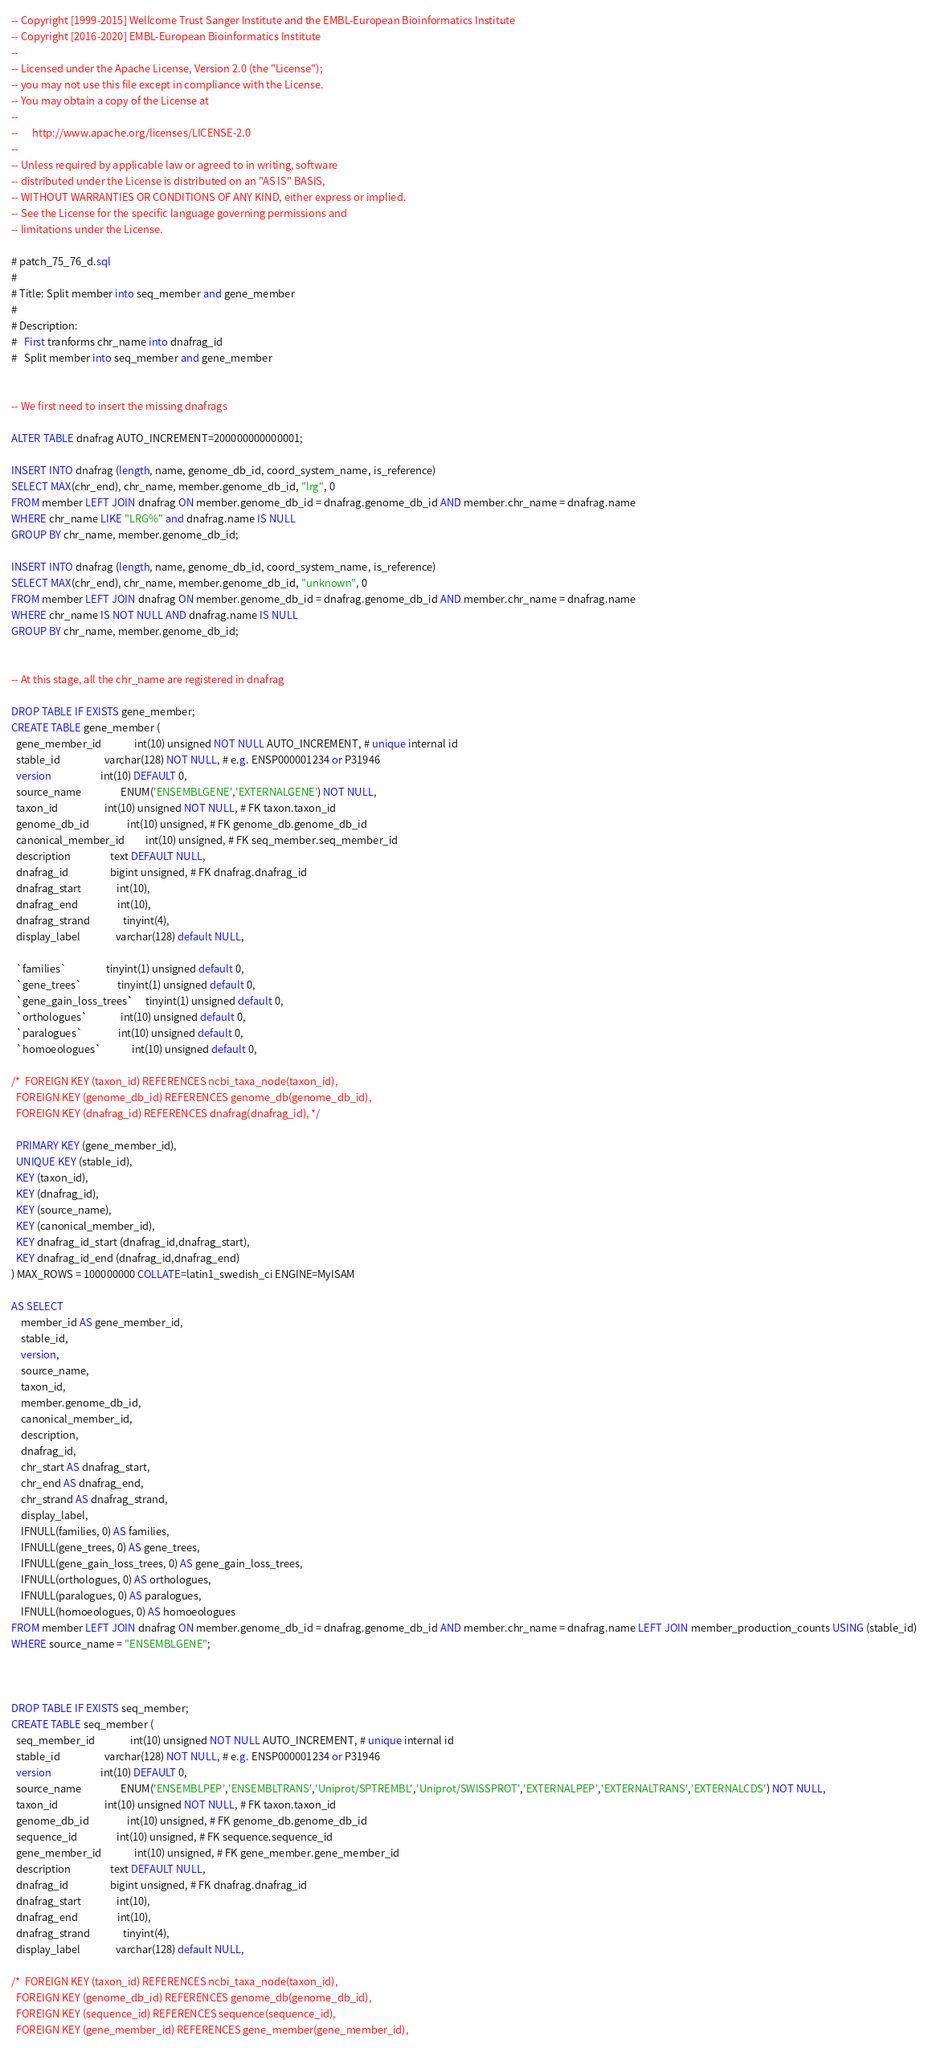Convert code to text. <code><loc_0><loc_0><loc_500><loc_500><_SQL_>-- Copyright [1999-2015] Wellcome Trust Sanger Institute and the EMBL-European Bioinformatics Institute
-- Copyright [2016-2020] EMBL-European Bioinformatics Institute
-- 
-- Licensed under the Apache License, Version 2.0 (the "License");
-- you may not use this file except in compliance with the License.
-- You may obtain a copy of the License at
-- 
--      http://www.apache.org/licenses/LICENSE-2.0
-- 
-- Unless required by applicable law or agreed to in writing, software
-- distributed under the License is distributed on an "AS IS" BASIS,
-- WITHOUT WARRANTIES OR CONDITIONS OF ANY KIND, either express or implied.
-- See the License for the specific language governing permissions and
-- limitations under the License.

# patch_75_76_d.sql
#
# Title: Split member into seq_member and gene_member
#
# Description:
#   First tranforms chr_name into dnafrag_id
#   Split member into seq_member and gene_member


-- We first need to insert the missing dnafrags

ALTER TABLE dnafrag AUTO_INCREMENT=200000000000001;

INSERT INTO dnafrag (length, name, genome_db_id, coord_system_name, is_reference)
SELECT MAX(chr_end), chr_name, member.genome_db_id, "lrg", 0
FROM member LEFT JOIN dnafrag ON member.genome_db_id = dnafrag.genome_db_id AND member.chr_name = dnafrag.name
WHERE chr_name LIKE "LRG%" and dnafrag.name IS NULL
GROUP BY chr_name, member.genome_db_id;

INSERT INTO dnafrag (length, name, genome_db_id, coord_system_name, is_reference)
SELECT MAX(chr_end), chr_name, member.genome_db_id, "unknown", 0
FROM member LEFT JOIN dnafrag ON member.genome_db_id = dnafrag.genome_db_id AND member.chr_name = dnafrag.name
WHERE chr_name IS NOT NULL AND dnafrag.name IS NULL
GROUP BY chr_name, member.genome_db_id;


-- At this stage, all the chr_name are registered in dnafrag

DROP TABLE IF EXISTS gene_member;
CREATE TABLE gene_member (
  gene_member_id              int(10) unsigned NOT NULL AUTO_INCREMENT, # unique internal id
  stable_id                   varchar(128) NOT NULL, # e.g. ENSP000001234 or P31946
  version                     int(10) DEFAULT 0,
  source_name                 ENUM('ENSEMBLGENE','EXTERNALGENE') NOT NULL,
  taxon_id                    int(10) unsigned NOT NULL, # FK taxon.taxon_id
  genome_db_id                int(10) unsigned, # FK genome_db.genome_db_id
  canonical_member_id         int(10) unsigned, # FK seq_member.seq_member_id
  description                 text DEFAULT NULL,
  dnafrag_id                  bigint unsigned, # FK dnafrag.dnafrag_id
  dnafrag_start               int(10),
  dnafrag_end                 int(10),
  dnafrag_strand              tinyint(4),
  display_label               varchar(128) default NULL,

  `families`                 tinyint(1) unsigned default 0,
  `gene_trees`               tinyint(1) unsigned default 0,
  `gene_gain_loss_trees`     tinyint(1) unsigned default 0,
  `orthologues`              int(10) unsigned default 0,
  `paralogues`               int(10) unsigned default 0,
  `homoeologues`             int(10) unsigned default 0,

/*  FOREIGN KEY (taxon_id) REFERENCES ncbi_taxa_node(taxon_id),
  FOREIGN KEY (genome_db_id) REFERENCES genome_db(genome_db_id),
  FOREIGN KEY (dnafrag_id) REFERENCES dnafrag(dnafrag_id), */

  PRIMARY KEY (gene_member_id),
  UNIQUE KEY (stable_id),
  KEY (taxon_id),
  KEY (dnafrag_id),
  KEY (source_name),
  KEY (canonical_member_id),
  KEY dnafrag_id_start (dnafrag_id,dnafrag_start),
  KEY dnafrag_id_end (dnafrag_id,dnafrag_end)
) MAX_ROWS = 100000000 COLLATE=latin1_swedish_ci ENGINE=MyISAM

AS SELECT
	member_id AS gene_member_id,
	stable_id,
	version,
	source_name,
	taxon_id,
	member.genome_db_id,
	canonical_member_id,
	description,
	dnafrag_id,
	chr_start AS dnafrag_start,
	chr_end AS dnafrag_end,
	chr_strand AS dnafrag_strand,
	display_label,
	IFNULL(families, 0) AS families,
	IFNULL(gene_trees, 0) AS gene_trees,
	IFNULL(gene_gain_loss_trees, 0) AS gene_gain_loss_trees,
	IFNULL(orthologues, 0) AS orthologues,
	IFNULL(paralogues, 0) AS paralogues,
	IFNULL(homoeologues, 0) AS homoeologues
FROM member LEFT JOIN dnafrag ON member.genome_db_id = dnafrag.genome_db_id AND member.chr_name = dnafrag.name LEFT JOIN member_production_counts USING (stable_id)
WHERE source_name = "ENSEMBLGENE";



DROP TABLE IF EXISTS seq_member;
CREATE TABLE seq_member (
  seq_member_id               int(10) unsigned NOT NULL AUTO_INCREMENT, # unique internal id
  stable_id                   varchar(128) NOT NULL, # e.g. ENSP000001234 or P31946
  version                     int(10) DEFAULT 0,
  source_name                 ENUM('ENSEMBLPEP','ENSEMBLTRANS','Uniprot/SPTREMBL','Uniprot/SWISSPROT','EXTERNALPEP','EXTERNALTRANS','EXTERNALCDS') NOT NULL,
  taxon_id                    int(10) unsigned NOT NULL, # FK taxon.taxon_id
  genome_db_id                int(10) unsigned, # FK genome_db.genome_db_id
  sequence_id                 int(10) unsigned, # FK sequence.sequence_id
  gene_member_id              int(10) unsigned, # FK gene_member.gene_member_id
  description                 text DEFAULT NULL,
  dnafrag_id                  bigint unsigned, # FK dnafrag.dnafrag_id
  dnafrag_start               int(10),
  dnafrag_end                 int(10),
  dnafrag_strand              tinyint(4),
  display_label               varchar(128) default NULL,

/*  FOREIGN KEY (taxon_id) REFERENCES ncbi_taxa_node(taxon_id),
  FOREIGN KEY (genome_db_id) REFERENCES genome_db(genome_db_id),
  FOREIGN KEY (sequence_id) REFERENCES sequence(sequence_id),
  FOREIGN KEY (gene_member_id) REFERENCES gene_member(gene_member_id),</code> 